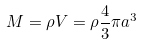Convert formula to latex. <formula><loc_0><loc_0><loc_500><loc_500>M = \rho V = \rho \frac { 4 } { 3 } \pi a ^ { 3 }</formula> 